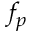Convert formula to latex. <formula><loc_0><loc_0><loc_500><loc_500>f _ { p }</formula> 